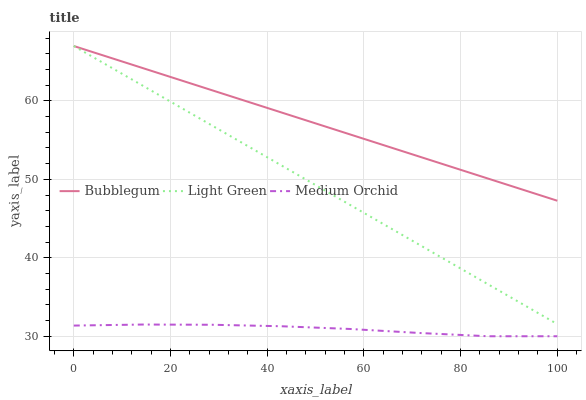Does Medium Orchid have the minimum area under the curve?
Answer yes or no. Yes. Does Bubblegum have the maximum area under the curve?
Answer yes or no. Yes. Does Light Green have the minimum area under the curve?
Answer yes or no. No. Does Light Green have the maximum area under the curve?
Answer yes or no. No. Is Light Green the smoothest?
Answer yes or no. Yes. Is Medium Orchid the roughest?
Answer yes or no. Yes. Is Bubblegum the smoothest?
Answer yes or no. No. Is Bubblegum the roughest?
Answer yes or no. No. Does Medium Orchid have the lowest value?
Answer yes or no. Yes. Does Light Green have the lowest value?
Answer yes or no. No. Does Bubblegum have the highest value?
Answer yes or no. Yes. Is Medium Orchid less than Bubblegum?
Answer yes or no. Yes. Is Bubblegum greater than Medium Orchid?
Answer yes or no. Yes. Does Light Green intersect Bubblegum?
Answer yes or no. Yes. Is Light Green less than Bubblegum?
Answer yes or no. No. Is Light Green greater than Bubblegum?
Answer yes or no. No. Does Medium Orchid intersect Bubblegum?
Answer yes or no. No. 